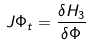Convert formula to latex. <formula><loc_0><loc_0><loc_500><loc_500>J \Phi _ { t } = \frac { \delta H _ { 3 } } { \delta \Phi }</formula> 